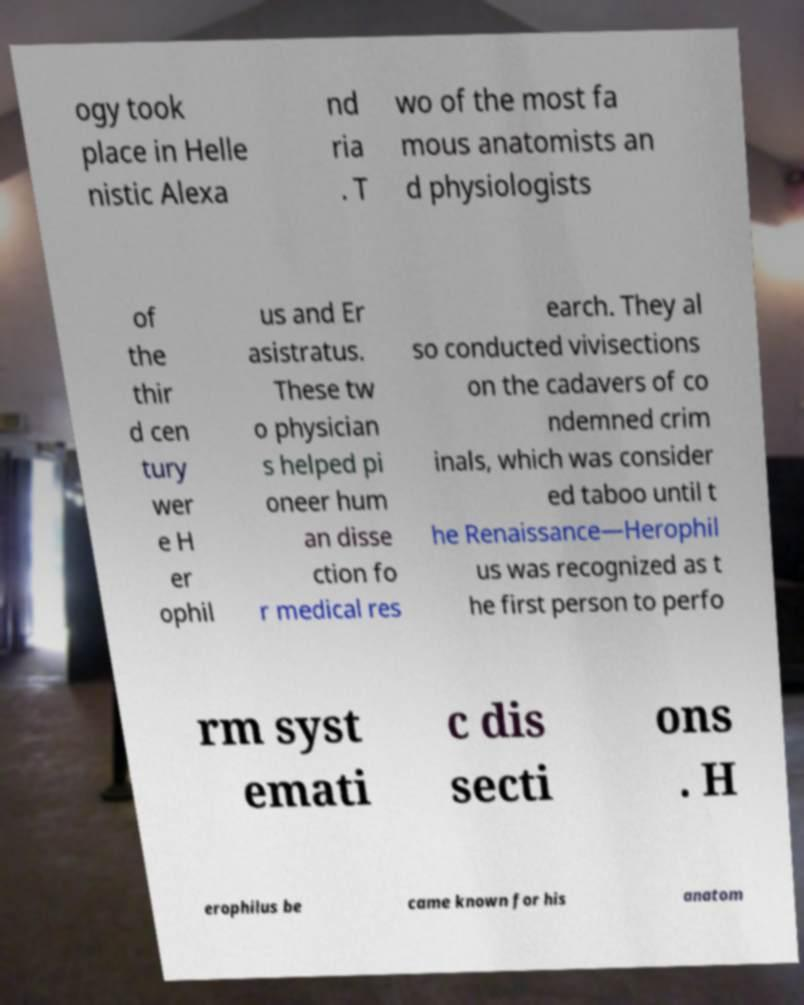I need the written content from this picture converted into text. Can you do that? ogy took place in Helle nistic Alexa nd ria . T wo of the most fa mous anatomists an d physiologists of the thir d cen tury wer e H er ophil us and Er asistratus. These tw o physician s helped pi oneer hum an disse ction fo r medical res earch. They al so conducted vivisections on the cadavers of co ndemned crim inals, which was consider ed taboo until t he Renaissance—Herophil us was recognized as t he first person to perfo rm syst emati c dis secti ons . H erophilus be came known for his anatom 